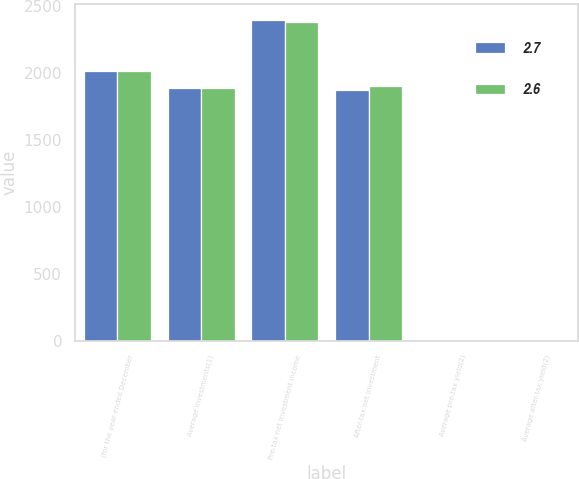<chart> <loc_0><loc_0><loc_500><loc_500><stacked_bar_chart><ecel><fcel>(for the year ended December<fcel>Average investments(1)<fcel>Pre-tax net investment income<fcel>After-tax net investment<fcel>Average pre-tax yield(2)<fcel>Average after-tax yield(2)<nl><fcel>2.7<fcel>2017<fcel>1888.5<fcel>2397<fcel>1872<fcel>3.3<fcel>2.6<nl><fcel>2.6<fcel>2015<fcel>1888.5<fcel>2379<fcel>1905<fcel>3.4<fcel>2.7<nl></chart> 